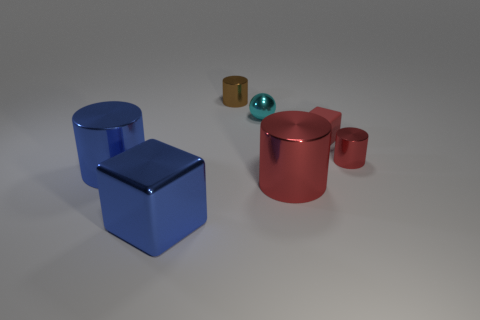Subtract all large blue metal cylinders. How many cylinders are left? 3 Add 2 small gray shiny blocks. How many objects exist? 9 Subtract all brown cylinders. How many cylinders are left? 3 Subtract 0 purple cylinders. How many objects are left? 7 Subtract all cylinders. How many objects are left? 3 Subtract 2 cylinders. How many cylinders are left? 2 Subtract all gray cylinders. Subtract all cyan spheres. How many cylinders are left? 4 Subtract all yellow balls. How many red cubes are left? 1 Subtract all small cyan metal objects. Subtract all tiny purple rubber balls. How many objects are left? 6 Add 6 large cubes. How many large cubes are left? 7 